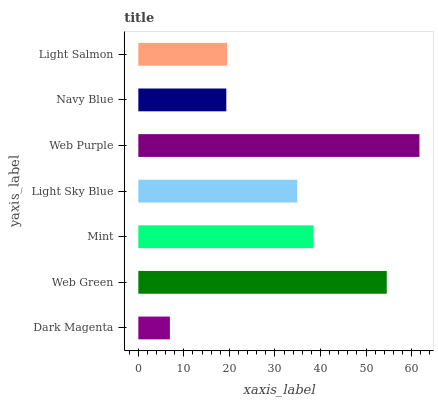Is Dark Magenta the minimum?
Answer yes or no. Yes. Is Web Purple the maximum?
Answer yes or no. Yes. Is Web Green the minimum?
Answer yes or no. No. Is Web Green the maximum?
Answer yes or no. No. Is Web Green greater than Dark Magenta?
Answer yes or no. Yes. Is Dark Magenta less than Web Green?
Answer yes or no. Yes. Is Dark Magenta greater than Web Green?
Answer yes or no. No. Is Web Green less than Dark Magenta?
Answer yes or no. No. Is Light Sky Blue the high median?
Answer yes or no. Yes. Is Light Sky Blue the low median?
Answer yes or no. Yes. Is Web Purple the high median?
Answer yes or no. No. Is Dark Magenta the low median?
Answer yes or no. No. 